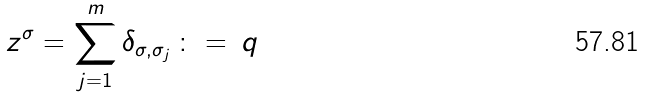<formula> <loc_0><loc_0><loc_500><loc_500>z ^ { \sigma } = \sum _ { j = 1 } ^ { m } \delta _ { \sigma , \sigma _ { j } } \, \colon = \, q</formula> 